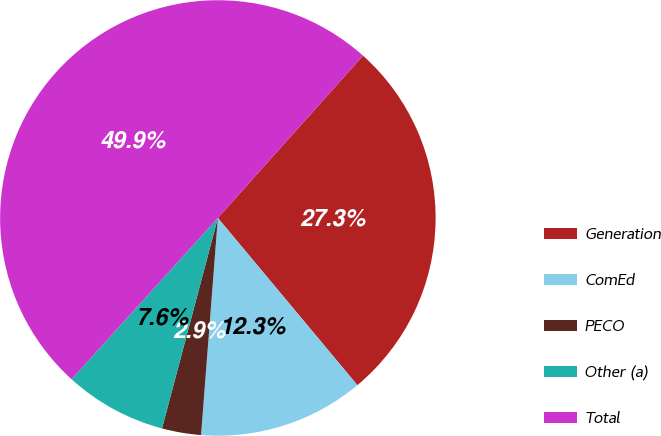Convert chart to OTSL. <chart><loc_0><loc_0><loc_500><loc_500><pie_chart><fcel>Generation<fcel>ComEd<fcel>PECO<fcel>Other (a)<fcel>Total<nl><fcel>27.32%<fcel>12.3%<fcel>2.9%<fcel>7.6%<fcel>49.89%<nl></chart> 